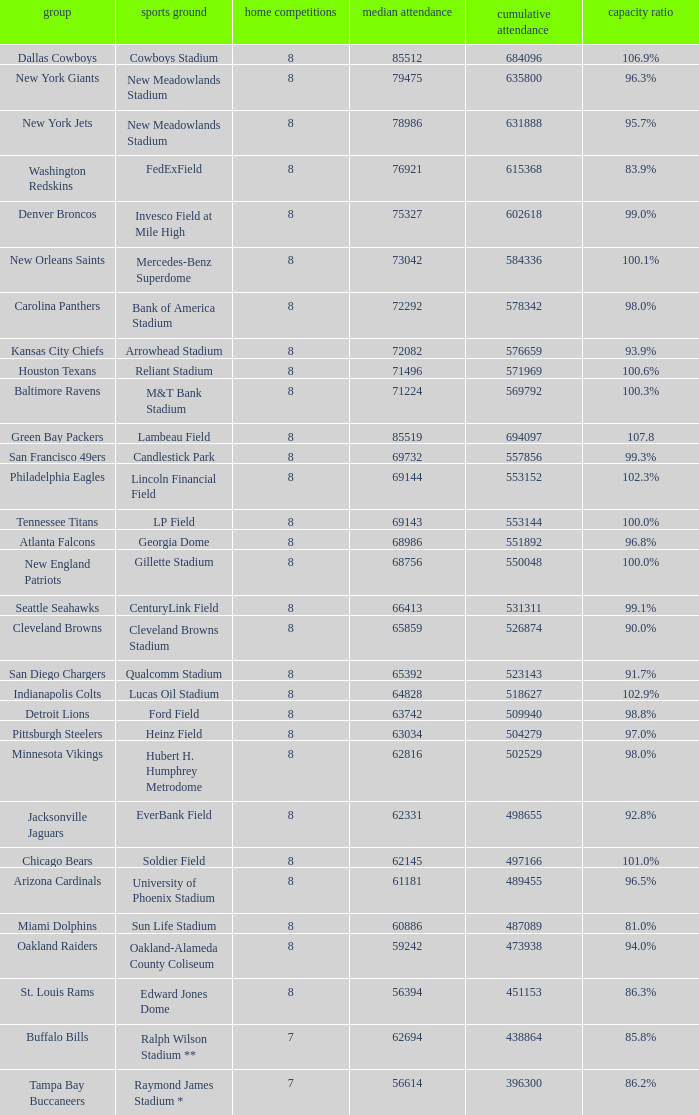What is the name of the team when the stadium is listed as Edward Jones Dome? St. Louis Rams. 